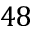<formula> <loc_0><loc_0><loc_500><loc_500>4 8</formula> 